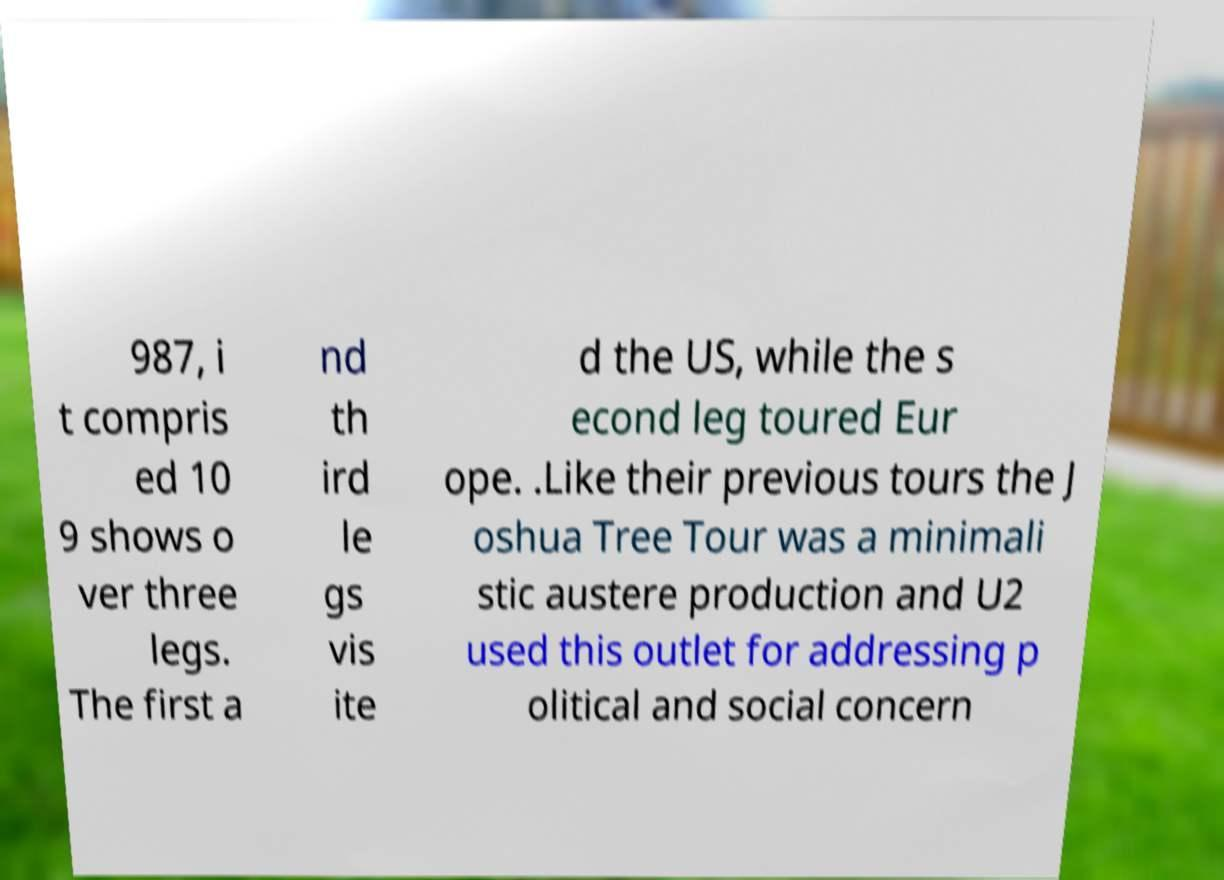Could you extract and type out the text from this image? 987, i t compris ed 10 9 shows o ver three legs. The first a nd th ird le gs vis ite d the US, while the s econd leg toured Eur ope. .Like their previous tours the J oshua Tree Tour was a minimali stic austere production and U2 used this outlet for addressing p olitical and social concern 